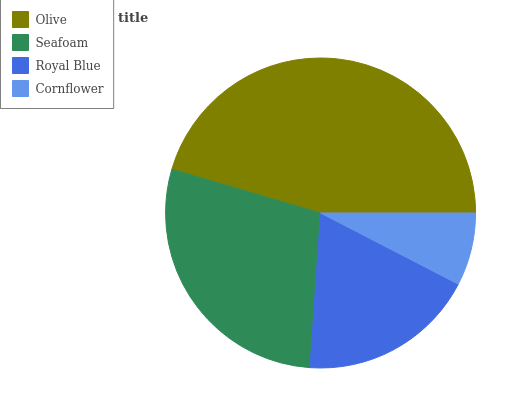Is Cornflower the minimum?
Answer yes or no. Yes. Is Olive the maximum?
Answer yes or no. Yes. Is Seafoam the minimum?
Answer yes or no. No. Is Seafoam the maximum?
Answer yes or no. No. Is Olive greater than Seafoam?
Answer yes or no. Yes. Is Seafoam less than Olive?
Answer yes or no. Yes. Is Seafoam greater than Olive?
Answer yes or no. No. Is Olive less than Seafoam?
Answer yes or no. No. Is Seafoam the high median?
Answer yes or no. Yes. Is Royal Blue the low median?
Answer yes or no. Yes. Is Cornflower the high median?
Answer yes or no. No. Is Cornflower the low median?
Answer yes or no. No. 